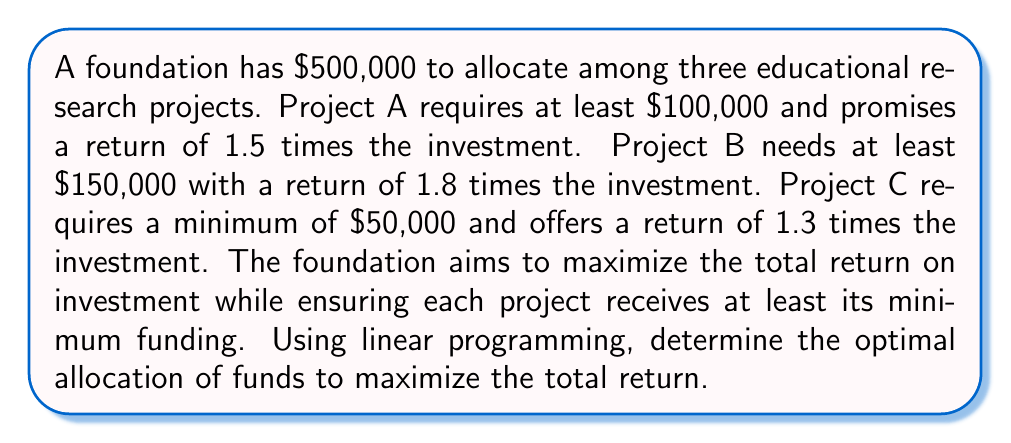Could you help me with this problem? Let's approach this step-by-step using linear programming:

1) Define variables:
   Let $x_A$, $x_B$, and $x_C$ be the amounts allocated to Projects A, B, and C respectively.

2) Objective function:
   Maximize $Z = 1.5x_A + 1.8x_B + 1.3x_C$

3) Constraints:
   a) Total available funds: $x_A + x_B + x_C \leq 500000$
   b) Minimum funding requirements:
      $x_A \geq 100000$
      $x_B \geq 150000$
      $x_C \geq 50000$
   c) Non-negativity: $x_A, x_B, x_C \geq 0$

4) Set up the linear programming tableau:

   $$
   \begin{array}{c|ccc|c}
    & x_A & x_B & x_C & RHS \\
   \hline
   Z & -1.5 & -1.8 & -1.3 & 0 \\
   S_1 & 1 & 1 & 1 & 500000 \\
   S_2 & 1 & 0 & 0 & 100000 \\
   S_3 & 0 & 1 & 0 & 150000 \\
   S_4 & 0 & 0 & 1 & 50000 \\
   \end{array}
   $$

5) Solve using the simplex method:
   After performing iterations, we reach the optimal solution:

   $$
   \begin{array}{c|ccc|c}
    & x_A & x_B & x_C & RHS \\
   \hline
   Z & 0 & 0 & 0 & 825000 \\
   x_A & 1 & 0 & 0 & 100000 \\
   x_B & 0 & 1 & 0 & 350000 \\
   x_C & 0 & 0 & 1 & 50000 \\
   S_1 & 0 & 0 & 0 & 0 \\
   \end{array}
   $$

6) Interpret the results:
   Optimal allocation:
   Project A: $100,000
   Project B: $350,000
   Project C: $50,000

   Maximum return: $825,000
Answer: Project A: $100,000; Project B: $350,000; Project C: $50,000; Maximum return: $825,000 